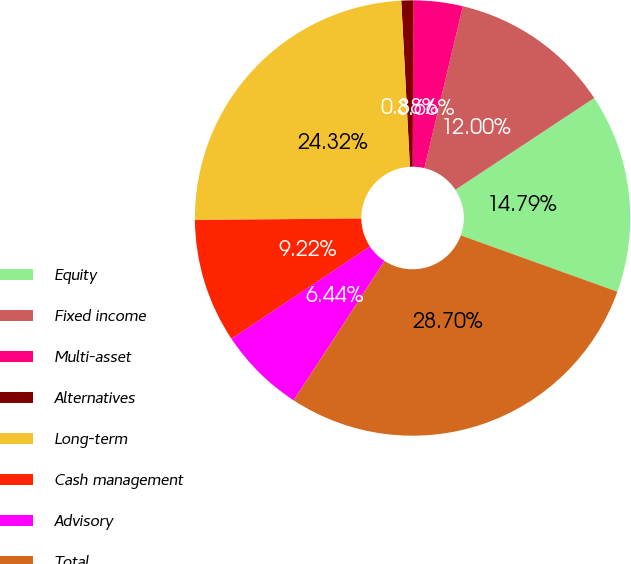Convert chart to OTSL. <chart><loc_0><loc_0><loc_500><loc_500><pie_chart><fcel>Equity<fcel>Fixed income<fcel>Multi-asset<fcel>Alternatives<fcel>Long-term<fcel>Cash management<fcel>Advisory<fcel>Total<nl><fcel>14.79%<fcel>12.0%<fcel>3.66%<fcel>0.88%<fcel>24.32%<fcel>9.22%<fcel>6.44%<fcel>28.7%<nl></chart> 